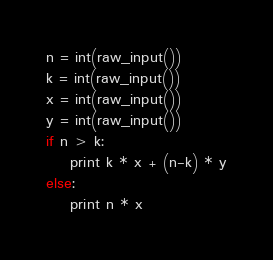<code> <loc_0><loc_0><loc_500><loc_500><_Python_>n = int(raw_input())
k = int(raw_input())
x = int(raw_input())
y = int(raw_input())
if n > k:
    print k * x + (n-k) * y
else:
    print n * x
</code> 